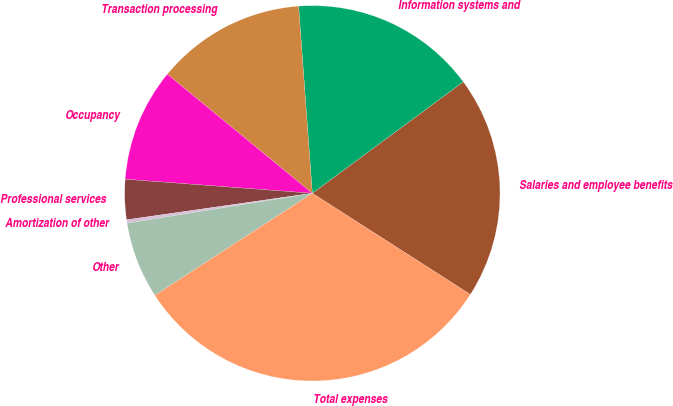Convert chart. <chart><loc_0><loc_0><loc_500><loc_500><pie_chart><fcel>Salaries and employee benefits<fcel>Information systems and<fcel>Transaction processing<fcel>Occupancy<fcel>Professional services<fcel>Amortization of other<fcel>Other<fcel>Total expenses<nl><fcel>19.19%<fcel>16.04%<fcel>12.89%<fcel>9.75%<fcel>3.45%<fcel>0.3%<fcel>6.6%<fcel>31.78%<nl></chart> 